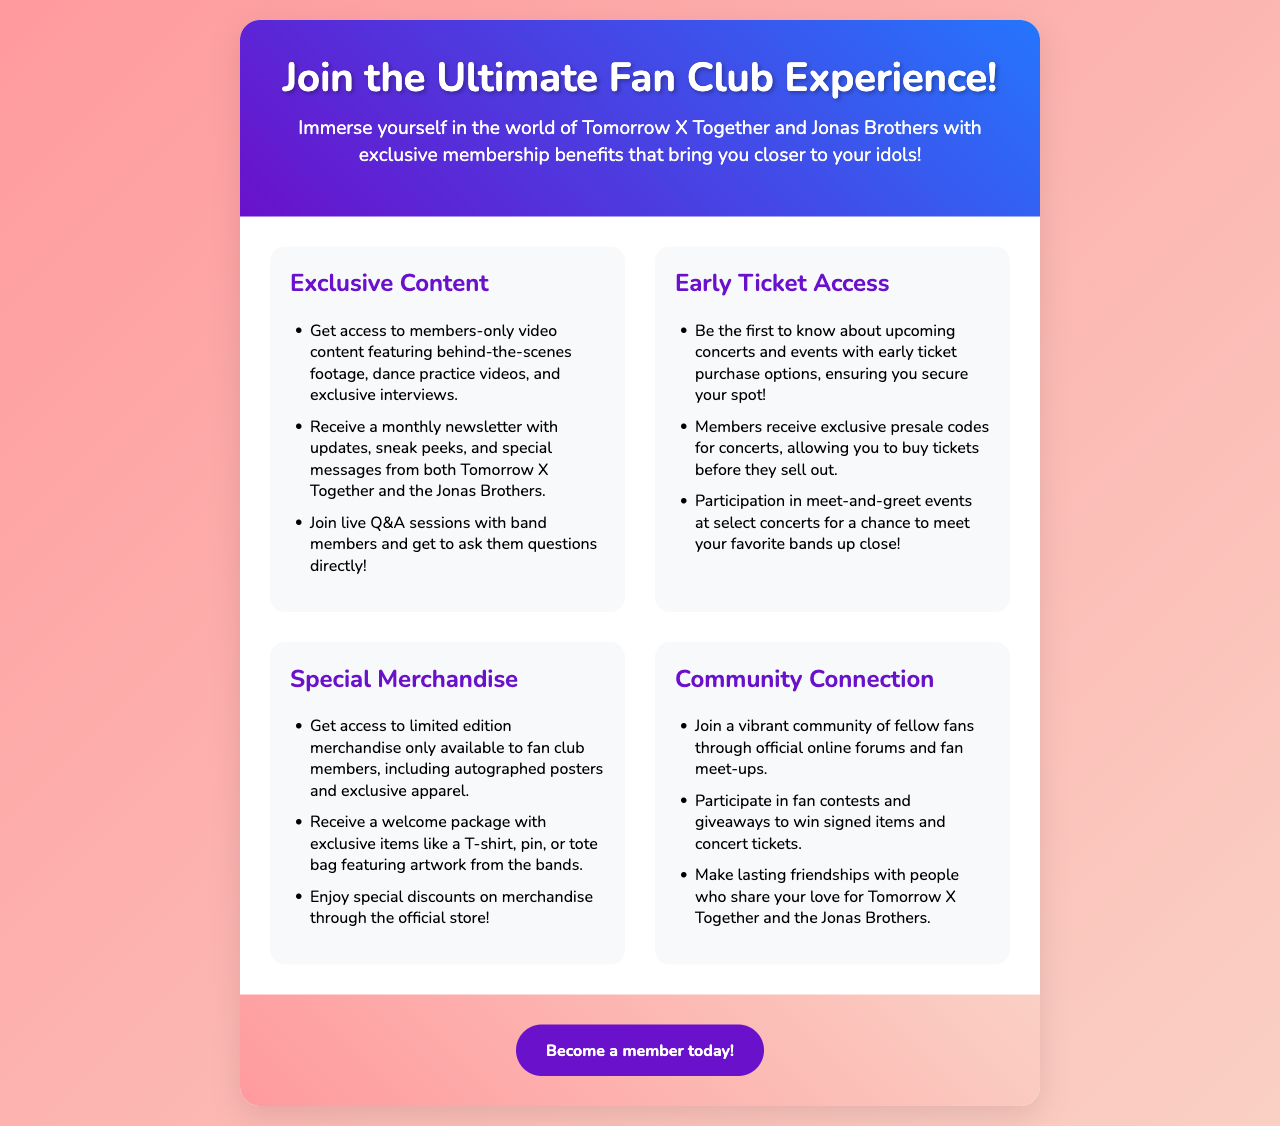What are the exclusive benefits mentioned in the brochure? The brochure outlines benefits such as exclusive content, early ticket access, special merchandise, and community connection.
Answer: Exclusive content, early ticket access, special merchandise, community connection How many types of exclusive content are available to members? The document lists three specific types of exclusive content available to members.
Answer: Three What event allows members to meet band members up close? According to the brochure, members can participate in meet-and-greet events at select concerts for a chance to meet the bands.
Answer: Meet-and-greet events What will a member receive in their welcome package? The brochure specifies that members will receive exclusive items such as a T-shirt, pin, or tote bag in their welcome package.
Answer: T-shirt, pin, or tote bag What is a benefit of the early ticket access section? The benefit includes receiving exclusive presale codes for concerts, allowing tickets to be purchased before they sell out.
Answer: Exclusive presale codes How can fans connect with each other as mentioned in the brochure? The document suggests joining a vibrant community through official online forums and fan meet-ups.
Answer: Online forums and fan meet-ups What type of merchandise is available only to fan club members? The brochure mentions that limited edition merchandise, including autographed posters, is available only to fan club members.
Answer: Limited edition merchandise What do the monthly newsletters include? The newsletters provide updates, sneak peeks, and special messages from both Tomorrow X Together and the Jonas Brothers.
Answer: Updates, sneak peeks, and special messages 